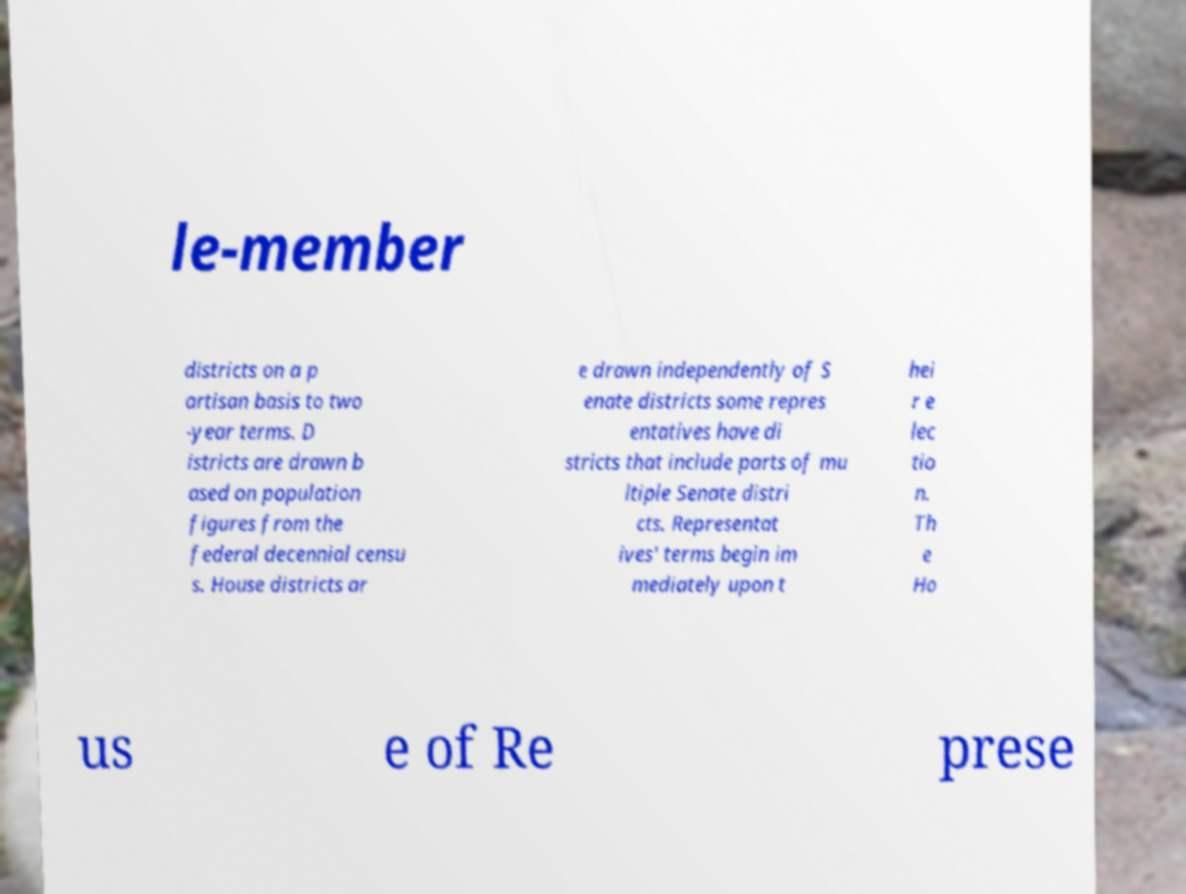I need the written content from this picture converted into text. Can you do that? le-member districts on a p artisan basis to two -year terms. D istricts are drawn b ased on population figures from the federal decennial censu s. House districts ar e drawn independently of S enate districts some repres entatives have di stricts that include parts of mu ltiple Senate distri cts. Representat ives' terms begin im mediately upon t hei r e lec tio n. Th e Ho us e of Re prese 